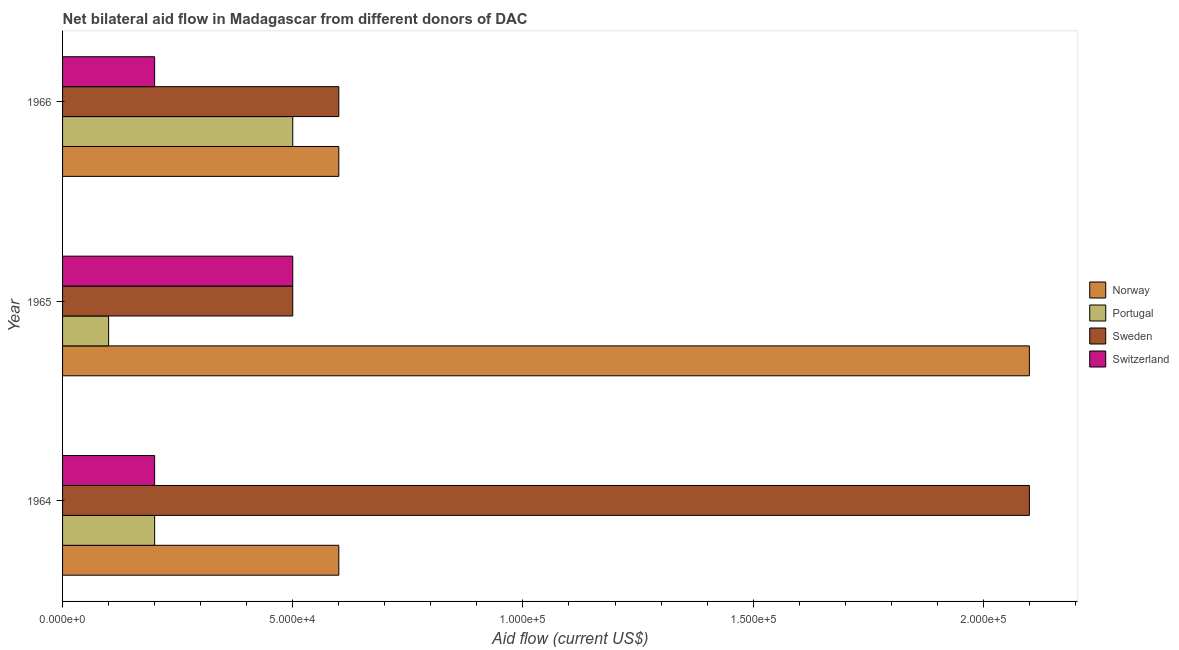Are the number of bars per tick equal to the number of legend labels?
Ensure brevity in your answer.  Yes. Are the number of bars on each tick of the Y-axis equal?
Your answer should be very brief. Yes. How many bars are there on the 2nd tick from the top?
Give a very brief answer. 4. How many bars are there on the 3rd tick from the bottom?
Your response must be concise. 4. What is the label of the 1st group of bars from the top?
Make the answer very short. 1966. What is the amount of aid given by switzerland in 1965?
Provide a short and direct response. 5.00e+04. Across all years, what is the maximum amount of aid given by sweden?
Offer a terse response. 2.10e+05. Across all years, what is the minimum amount of aid given by sweden?
Ensure brevity in your answer.  5.00e+04. In which year was the amount of aid given by sweden maximum?
Give a very brief answer. 1964. In which year was the amount of aid given by sweden minimum?
Your answer should be compact. 1965. What is the total amount of aid given by switzerland in the graph?
Ensure brevity in your answer.  9.00e+04. What is the difference between the amount of aid given by norway in 1965 and that in 1966?
Keep it short and to the point. 1.50e+05. What is the difference between the amount of aid given by norway in 1965 and the amount of aid given by sweden in 1966?
Offer a terse response. 1.50e+05. In the year 1966, what is the difference between the amount of aid given by portugal and amount of aid given by norway?
Provide a short and direct response. -10000. In how many years, is the amount of aid given by sweden greater than 50000 US$?
Give a very brief answer. 2. What is the ratio of the amount of aid given by portugal in 1964 to that in 1966?
Give a very brief answer. 0.4. What is the difference between the highest and the second highest amount of aid given by switzerland?
Make the answer very short. 3.00e+04. What is the difference between the highest and the lowest amount of aid given by sweden?
Your answer should be compact. 1.60e+05. Is it the case that in every year, the sum of the amount of aid given by sweden and amount of aid given by portugal is greater than the sum of amount of aid given by switzerland and amount of aid given by norway?
Provide a short and direct response. No. What does the 4th bar from the bottom in 1966 represents?
Provide a succinct answer. Switzerland. How many bars are there?
Ensure brevity in your answer.  12. What is the difference between two consecutive major ticks on the X-axis?
Keep it short and to the point. 5.00e+04. Are the values on the major ticks of X-axis written in scientific E-notation?
Your answer should be compact. Yes. Where does the legend appear in the graph?
Your response must be concise. Center right. How many legend labels are there?
Keep it short and to the point. 4. What is the title of the graph?
Ensure brevity in your answer.  Net bilateral aid flow in Madagascar from different donors of DAC. What is the label or title of the Y-axis?
Make the answer very short. Year. What is the Aid flow (current US$) of Portugal in 1964?
Your response must be concise. 2.00e+04. What is the Aid flow (current US$) in Norway in 1965?
Your answer should be very brief. 2.10e+05. What is the Aid flow (current US$) of Portugal in 1965?
Offer a very short reply. 10000. Across all years, what is the maximum Aid flow (current US$) in Portugal?
Your answer should be very brief. 5.00e+04. Across all years, what is the minimum Aid flow (current US$) in Switzerland?
Your answer should be very brief. 2.00e+04. What is the total Aid flow (current US$) in Portugal in the graph?
Your response must be concise. 8.00e+04. What is the total Aid flow (current US$) in Sweden in the graph?
Your answer should be very brief. 3.20e+05. What is the total Aid flow (current US$) of Switzerland in the graph?
Your response must be concise. 9.00e+04. What is the difference between the Aid flow (current US$) of Norway in 1964 and that in 1965?
Give a very brief answer. -1.50e+05. What is the difference between the Aid flow (current US$) of Switzerland in 1964 and that in 1965?
Offer a very short reply. -3.00e+04. What is the difference between the Aid flow (current US$) of Norway in 1964 and that in 1966?
Your response must be concise. 0. What is the difference between the Aid flow (current US$) of Norway in 1965 and that in 1966?
Provide a succinct answer. 1.50e+05. What is the difference between the Aid flow (current US$) in Portugal in 1965 and that in 1966?
Give a very brief answer. -4.00e+04. What is the difference between the Aid flow (current US$) in Sweden in 1965 and that in 1966?
Keep it short and to the point. -10000. What is the difference between the Aid flow (current US$) of Switzerland in 1965 and that in 1966?
Provide a succinct answer. 3.00e+04. What is the difference between the Aid flow (current US$) in Norway in 1964 and the Aid flow (current US$) in Portugal in 1965?
Offer a terse response. 5.00e+04. What is the difference between the Aid flow (current US$) of Norway in 1964 and the Aid flow (current US$) of Sweden in 1965?
Keep it short and to the point. 10000. What is the difference between the Aid flow (current US$) of Norway in 1964 and the Aid flow (current US$) of Portugal in 1966?
Ensure brevity in your answer.  10000. What is the difference between the Aid flow (current US$) of Portugal in 1964 and the Aid flow (current US$) of Sweden in 1966?
Offer a very short reply. -4.00e+04. What is the difference between the Aid flow (current US$) in Portugal in 1964 and the Aid flow (current US$) in Switzerland in 1966?
Offer a terse response. 0. What is the difference between the Aid flow (current US$) in Portugal in 1965 and the Aid flow (current US$) in Sweden in 1966?
Offer a terse response. -5.00e+04. What is the difference between the Aid flow (current US$) in Portugal in 1965 and the Aid flow (current US$) in Switzerland in 1966?
Offer a very short reply. -10000. What is the average Aid flow (current US$) in Portugal per year?
Offer a terse response. 2.67e+04. What is the average Aid flow (current US$) of Sweden per year?
Your answer should be compact. 1.07e+05. In the year 1964, what is the difference between the Aid flow (current US$) of Norway and Aid flow (current US$) of Portugal?
Offer a terse response. 4.00e+04. In the year 1964, what is the difference between the Aid flow (current US$) in Norway and Aid flow (current US$) in Switzerland?
Offer a very short reply. 4.00e+04. In the year 1964, what is the difference between the Aid flow (current US$) of Portugal and Aid flow (current US$) of Sweden?
Give a very brief answer. -1.90e+05. In the year 1964, what is the difference between the Aid flow (current US$) of Sweden and Aid flow (current US$) of Switzerland?
Give a very brief answer. 1.90e+05. In the year 1965, what is the difference between the Aid flow (current US$) in Norway and Aid flow (current US$) in Switzerland?
Provide a succinct answer. 1.60e+05. In the year 1965, what is the difference between the Aid flow (current US$) in Portugal and Aid flow (current US$) in Switzerland?
Your answer should be compact. -4.00e+04. In the year 1965, what is the difference between the Aid flow (current US$) in Sweden and Aid flow (current US$) in Switzerland?
Keep it short and to the point. 0. In the year 1966, what is the difference between the Aid flow (current US$) of Norway and Aid flow (current US$) of Portugal?
Offer a terse response. 10000. In the year 1966, what is the difference between the Aid flow (current US$) of Norway and Aid flow (current US$) of Sweden?
Give a very brief answer. 0. In the year 1966, what is the difference between the Aid flow (current US$) in Portugal and Aid flow (current US$) in Sweden?
Keep it short and to the point. -10000. In the year 1966, what is the difference between the Aid flow (current US$) of Portugal and Aid flow (current US$) of Switzerland?
Provide a succinct answer. 3.00e+04. In the year 1966, what is the difference between the Aid flow (current US$) in Sweden and Aid flow (current US$) in Switzerland?
Keep it short and to the point. 4.00e+04. What is the ratio of the Aid flow (current US$) of Norway in 1964 to that in 1965?
Your answer should be very brief. 0.29. What is the ratio of the Aid flow (current US$) in Portugal in 1964 to that in 1965?
Your response must be concise. 2. What is the ratio of the Aid flow (current US$) in Switzerland in 1964 to that in 1965?
Your answer should be very brief. 0.4. What is the ratio of the Aid flow (current US$) of Norway in 1964 to that in 1966?
Your answer should be compact. 1. What is the ratio of the Aid flow (current US$) of Portugal in 1964 to that in 1966?
Provide a succinct answer. 0.4. What is the ratio of the Aid flow (current US$) of Sweden in 1964 to that in 1966?
Offer a terse response. 3.5. What is the ratio of the Aid flow (current US$) of Norway in 1965 to that in 1966?
Your answer should be very brief. 3.5. What is the ratio of the Aid flow (current US$) of Portugal in 1965 to that in 1966?
Provide a short and direct response. 0.2. What is the ratio of the Aid flow (current US$) of Sweden in 1965 to that in 1966?
Offer a terse response. 0.83. What is the ratio of the Aid flow (current US$) in Switzerland in 1965 to that in 1966?
Provide a short and direct response. 2.5. What is the difference between the highest and the second highest Aid flow (current US$) in Norway?
Ensure brevity in your answer.  1.50e+05. What is the difference between the highest and the second highest Aid flow (current US$) in Portugal?
Make the answer very short. 3.00e+04. What is the difference between the highest and the lowest Aid flow (current US$) in Norway?
Offer a terse response. 1.50e+05. 